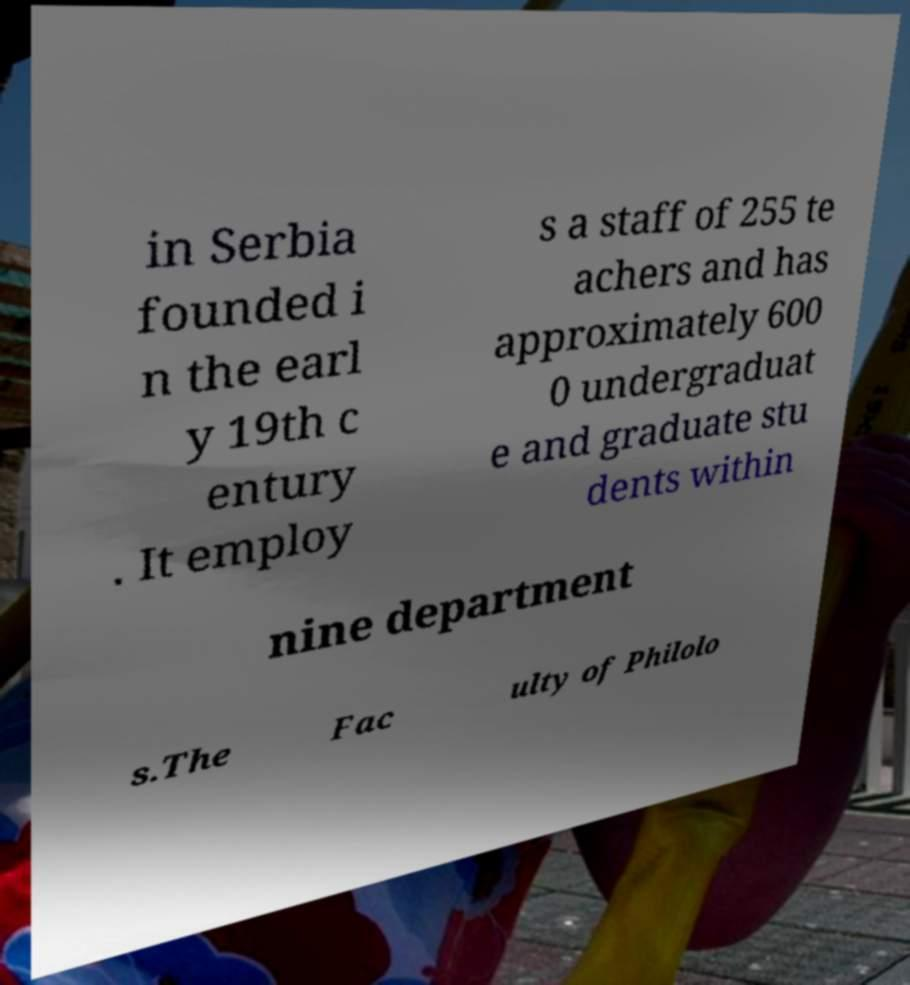Can you read and provide the text displayed in the image?This photo seems to have some interesting text. Can you extract and type it out for me? in Serbia founded i n the earl y 19th c entury . It employ s a staff of 255 te achers and has approximately 600 0 undergraduat e and graduate stu dents within nine department s.The Fac ulty of Philolo 